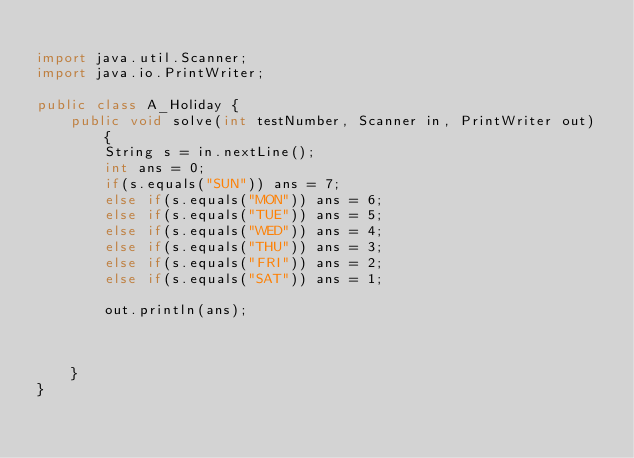<code> <loc_0><loc_0><loc_500><loc_500><_Java_>
import java.util.Scanner;
import java.io.PrintWriter;

public class A_Holiday {
    public void solve(int testNumber, Scanner in, PrintWriter out) {
        String s = in.nextLine();
        int ans = 0;
        if(s.equals("SUN")) ans = 7;
        else if(s.equals("MON")) ans = 6;
        else if(s.equals("TUE")) ans = 5;
        else if(s.equals("WED")) ans = 4;
        else if(s.equals("THU")) ans = 3;
        else if(s.equals("FRI")) ans = 2;
        else if(s.equals("SAT")) ans = 1;

        out.println(ans);



    }
}
</code> 